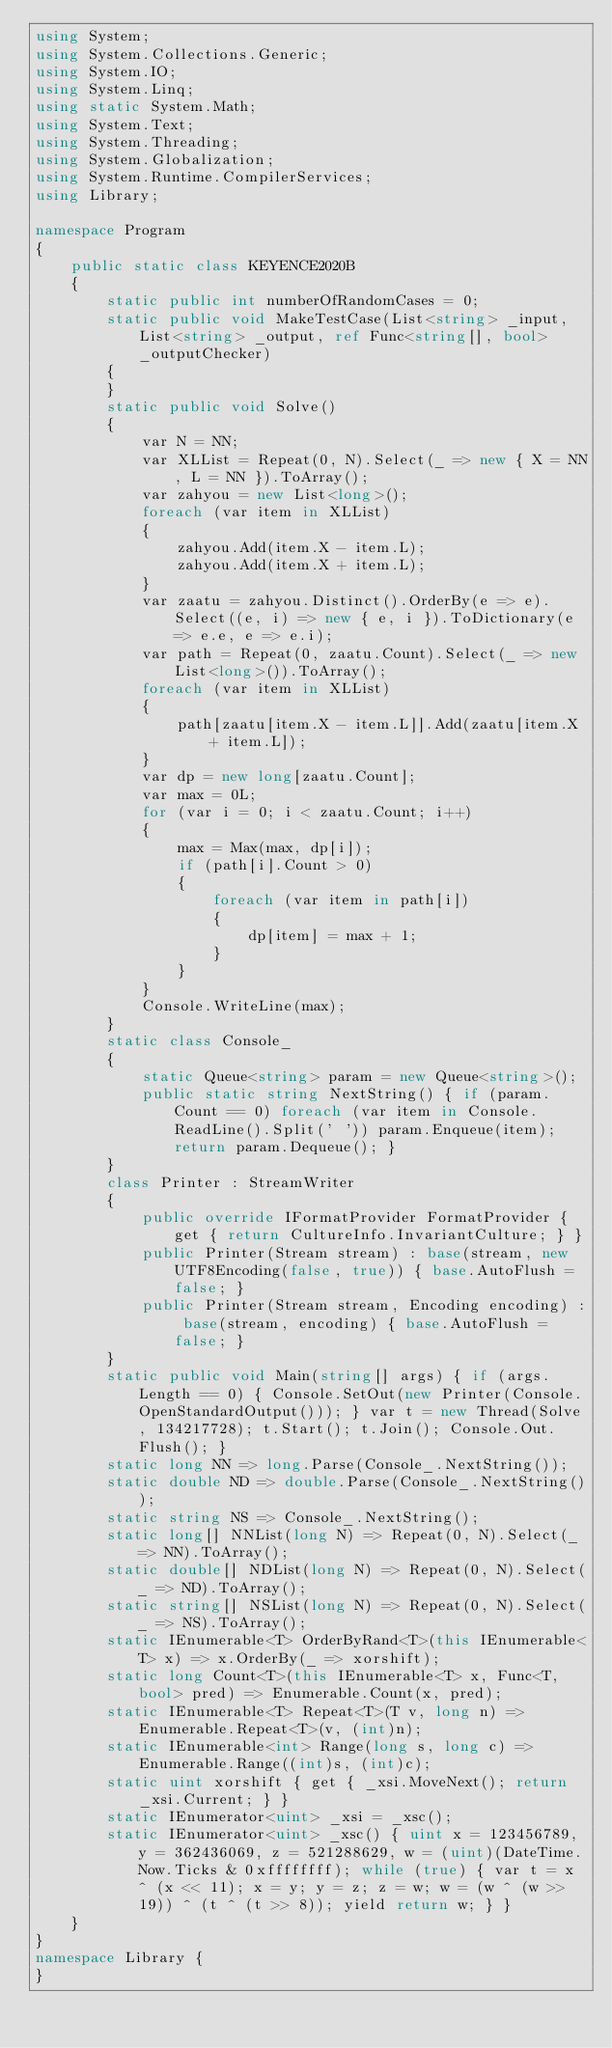<code> <loc_0><loc_0><loc_500><loc_500><_C#_>using System;
using System.Collections.Generic;
using System.IO;
using System.Linq;
using static System.Math;
using System.Text;
using System.Threading;
using System.Globalization;
using System.Runtime.CompilerServices;
using Library;

namespace Program
{
    public static class KEYENCE2020B
    {
        static public int numberOfRandomCases = 0;
        static public void MakeTestCase(List<string> _input, List<string> _output, ref Func<string[], bool> _outputChecker)
        {
        }
        static public void Solve()
        {
            var N = NN;
            var XLList = Repeat(0, N).Select(_ => new { X = NN, L = NN }).ToArray();
            var zahyou = new List<long>();
            foreach (var item in XLList)
            {
                zahyou.Add(item.X - item.L);
                zahyou.Add(item.X + item.L);
            }
            var zaatu = zahyou.Distinct().OrderBy(e => e).Select((e, i) => new { e, i }).ToDictionary(e => e.e, e => e.i);
            var path = Repeat(0, zaatu.Count).Select(_ => new List<long>()).ToArray();
            foreach (var item in XLList)
            {
                path[zaatu[item.X - item.L]].Add(zaatu[item.X + item.L]);
            }
            var dp = new long[zaatu.Count];
            var max = 0L;
            for (var i = 0; i < zaatu.Count; i++)
            {
                max = Max(max, dp[i]);
                if (path[i].Count > 0)
                {
                    foreach (var item in path[i])
                    {
                        dp[item] = max + 1;
                    }
                }
            }
            Console.WriteLine(max);
        }
        static class Console_
        {
            static Queue<string> param = new Queue<string>();
            public static string NextString() { if (param.Count == 0) foreach (var item in Console.ReadLine().Split(' ')) param.Enqueue(item); return param.Dequeue(); }
        }
        class Printer : StreamWriter
        {
            public override IFormatProvider FormatProvider { get { return CultureInfo.InvariantCulture; } }
            public Printer(Stream stream) : base(stream, new UTF8Encoding(false, true)) { base.AutoFlush = false; }
            public Printer(Stream stream, Encoding encoding) : base(stream, encoding) { base.AutoFlush = false; }
        }
        static public void Main(string[] args) { if (args.Length == 0) { Console.SetOut(new Printer(Console.OpenStandardOutput())); } var t = new Thread(Solve, 134217728); t.Start(); t.Join(); Console.Out.Flush(); }
        static long NN => long.Parse(Console_.NextString());
        static double ND => double.Parse(Console_.NextString());
        static string NS => Console_.NextString();
        static long[] NNList(long N) => Repeat(0, N).Select(_ => NN).ToArray();
        static double[] NDList(long N) => Repeat(0, N).Select(_ => ND).ToArray();
        static string[] NSList(long N) => Repeat(0, N).Select(_ => NS).ToArray();
        static IEnumerable<T> OrderByRand<T>(this IEnumerable<T> x) => x.OrderBy(_ => xorshift);
        static long Count<T>(this IEnumerable<T> x, Func<T, bool> pred) => Enumerable.Count(x, pred);
        static IEnumerable<T> Repeat<T>(T v, long n) => Enumerable.Repeat<T>(v, (int)n);
        static IEnumerable<int> Range(long s, long c) => Enumerable.Range((int)s, (int)c);
        static uint xorshift { get { _xsi.MoveNext(); return _xsi.Current; } }
        static IEnumerator<uint> _xsi = _xsc();
        static IEnumerator<uint> _xsc() { uint x = 123456789, y = 362436069, z = 521288629, w = (uint)(DateTime.Now.Ticks & 0xffffffff); while (true) { var t = x ^ (x << 11); x = y; y = z; z = w; w = (w ^ (w >> 19)) ^ (t ^ (t >> 8)); yield return w; } }
    }
}
namespace Library {
}
</code> 